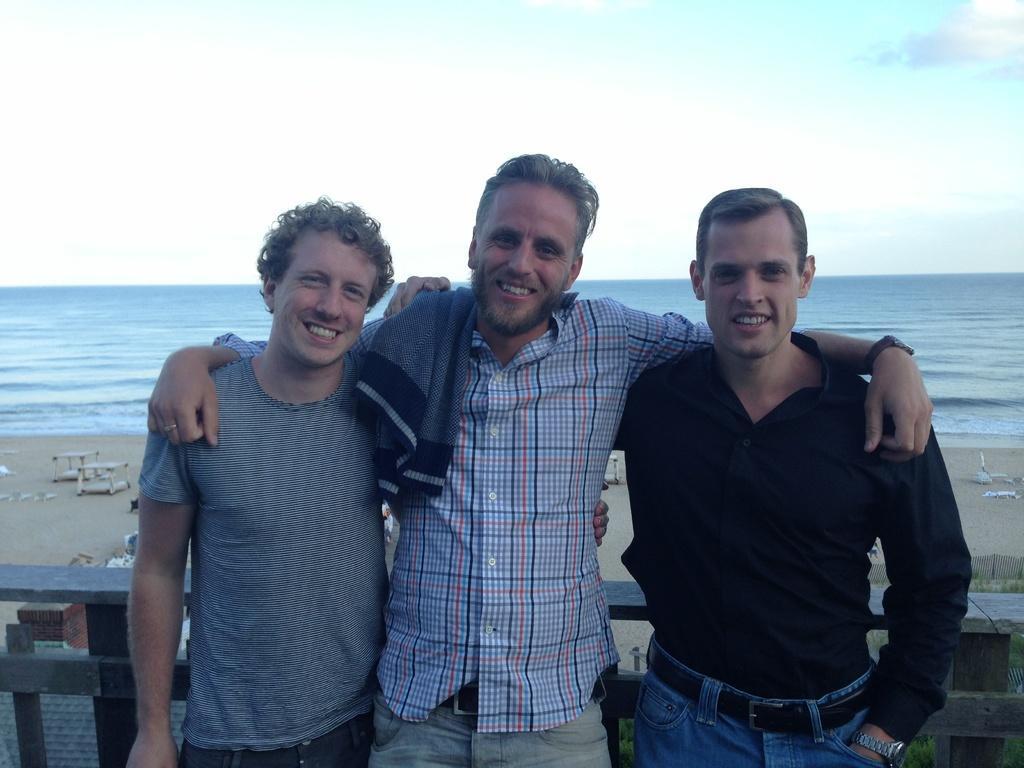Please provide a concise description of this image. In the middle a man is standing, he wore shirt,trouser. Beside him 2 men are standing, behind them there is the beach at the top it is the sky. 